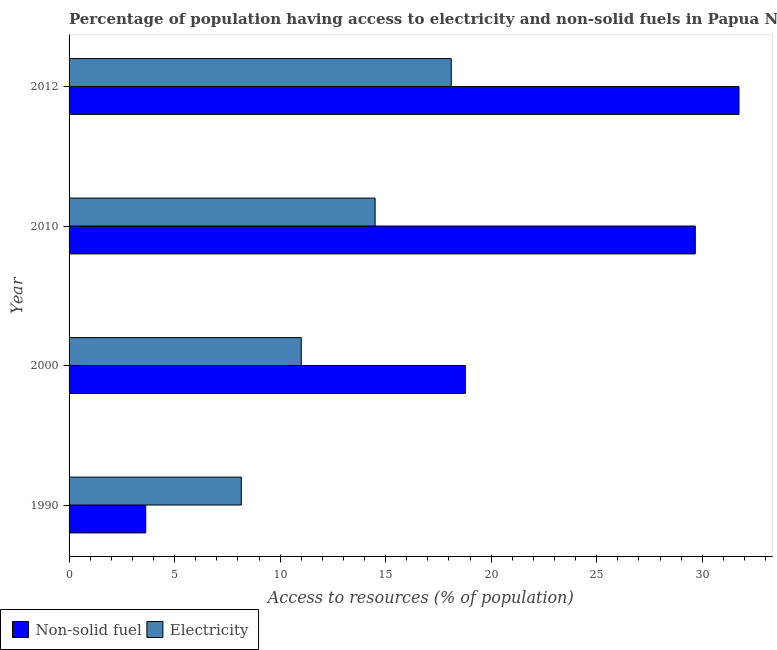How many different coloured bars are there?
Your response must be concise. 2. Are the number of bars on each tick of the Y-axis equal?
Your answer should be compact. Yes. How many bars are there on the 2nd tick from the bottom?
Provide a short and direct response. 2. What is the percentage of population having access to non-solid fuel in 2010?
Provide a short and direct response. 29.67. Across all years, what is the maximum percentage of population having access to electricity?
Make the answer very short. 18.11. Across all years, what is the minimum percentage of population having access to electricity?
Ensure brevity in your answer.  8.16. What is the total percentage of population having access to electricity in the graph?
Your answer should be compact. 51.77. What is the difference between the percentage of population having access to electricity in 1990 and that in 2000?
Keep it short and to the point. -2.84. What is the difference between the percentage of population having access to non-solid fuel in 2000 and the percentage of population having access to electricity in 2010?
Keep it short and to the point. 4.27. What is the average percentage of population having access to electricity per year?
Ensure brevity in your answer.  12.94. In the year 2010, what is the difference between the percentage of population having access to electricity and percentage of population having access to non-solid fuel?
Provide a short and direct response. -15.17. In how many years, is the percentage of population having access to non-solid fuel greater than 20 %?
Provide a succinct answer. 2. What is the ratio of the percentage of population having access to electricity in 1990 to that in 2000?
Provide a short and direct response. 0.74. Is the percentage of population having access to non-solid fuel in 2010 less than that in 2012?
Offer a very short reply. Yes. Is the difference between the percentage of population having access to electricity in 2000 and 2012 greater than the difference between the percentage of population having access to non-solid fuel in 2000 and 2012?
Keep it short and to the point. Yes. What is the difference between the highest and the second highest percentage of population having access to electricity?
Make the answer very short. 3.61. What is the difference between the highest and the lowest percentage of population having access to electricity?
Make the answer very short. 9.95. Is the sum of the percentage of population having access to non-solid fuel in 2000 and 2010 greater than the maximum percentage of population having access to electricity across all years?
Offer a very short reply. Yes. What does the 2nd bar from the top in 2000 represents?
Your answer should be very brief. Non-solid fuel. What does the 2nd bar from the bottom in 2010 represents?
Your answer should be compact. Electricity. How many bars are there?
Ensure brevity in your answer.  8. Are all the bars in the graph horizontal?
Provide a succinct answer. Yes. Are the values on the major ticks of X-axis written in scientific E-notation?
Ensure brevity in your answer.  No. Does the graph contain any zero values?
Your answer should be very brief. No. Does the graph contain grids?
Make the answer very short. No. Where does the legend appear in the graph?
Keep it short and to the point. Bottom left. How are the legend labels stacked?
Offer a terse response. Horizontal. What is the title of the graph?
Offer a very short reply. Percentage of population having access to electricity and non-solid fuels in Papua New Guinea. What is the label or title of the X-axis?
Your answer should be compact. Access to resources (% of population). What is the label or title of the Y-axis?
Offer a very short reply. Year. What is the Access to resources (% of population) in Non-solid fuel in 1990?
Offer a very short reply. 3.63. What is the Access to resources (% of population) in Electricity in 1990?
Your answer should be compact. 8.16. What is the Access to resources (% of population) of Non-solid fuel in 2000?
Make the answer very short. 18.77. What is the Access to resources (% of population) in Electricity in 2000?
Offer a very short reply. 11. What is the Access to resources (% of population) in Non-solid fuel in 2010?
Provide a succinct answer. 29.67. What is the Access to resources (% of population) in Non-solid fuel in 2012?
Offer a terse response. 31.74. What is the Access to resources (% of population) of Electricity in 2012?
Your response must be concise. 18.11. Across all years, what is the maximum Access to resources (% of population) in Non-solid fuel?
Provide a succinct answer. 31.74. Across all years, what is the maximum Access to resources (% of population) in Electricity?
Your response must be concise. 18.11. Across all years, what is the minimum Access to resources (% of population) of Non-solid fuel?
Make the answer very short. 3.63. Across all years, what is the minimum Access to resources (% of population) of Electricity?
Ensure brevity in your answer.  8.16. What is the total Access to resources (% of population) in Non-solid fuel in the graph?
Make the answer very short. 83.81. What is the total Access to resources (% of population) of Electricity in the graph?
Your answer should be very brief. 51.77. What is the difference between the Access to resources (% of population) of Non-solid fuel in 1990 and that in 2000?
Offer a very short reply. -15.14. What is the difference between the Access to resources (% of population) in Electricity in 1990 and that in 2000?
Offer a terse response. -2.84. What is the difference between the Access to resources (% of population) in Non-solid fuel in 1990 and that in 2010?
Keep it short and to the point. -26.04. What is the difference between the Access to resources (% of population) of Electricity in 1990 and that in 2010?
Provide a succinct answer. -6.34. What is the difference between the Access to resources (% of population) in Non-solid fuel in 1990 and that in 2012?
Your answer should be very brief. -28.11. What is the difference between the Access to resources (% of population) of Electricity in 1990 and that in 2012?
Provide a short and direct response. -9.95. What is the difference between the Access to resources (% of population) of Non-solid fuel in 2000 and that in 2010?
Keep it short and to the point. -10.9. What is the difference between the Access to resources (% of population) in Electricity in 2000 and that in 2010?
Offer a terse response. -3.5. What is the difference between the Access to resources (% of population) in Non-solid fuel in 2000 and that in 2012?
Offer a very short reply. -12.97. What is the difference between the Access to resources (% of population) of Electricity in 2000 and that in 2012?
Your answer should be very brief. -7.11. What is the difference between the Access to resources (% of population) in Non-solid fuel in 2010 and that in 2012?
Keep it short and to the point. -2.07. What is the difference between the Access to resources (% of population) of Electricity in 2010 and that in 2012?
Keep it short and to the point. -3.61. What is the difference between the Access to resources (% of population) in Non-solid fuel in 1990 and the Access to resources (% of population) in Electricity in 2000?
Your answer should be compact. -7.37. What is the difference between the Access to resources (% of population) of Non-solid fuel in 1990 and the Access to resources (% of population) of Electricity in 2010?
Ensure brevity in your answer.  -10.87. What is the difference between the Access to resources (% of population) of Non-solid fuel in 1990 and the Access to resources (% of population) of Electricity in 2012?
Offer a very short reply. -14.48. What is the difference between the Access to resources (% of population) of Non-solid fuel in 2000 and the Access to resources (% of population) of Electricity in 2010?
Provide a succinct answer. 4.27. What is the difference between the Access to resources (% of population) in Non-solid fuel in 2000 and the Access to resources (% of population) in Electricity in 2012?
Keep it short and to the point. 0.67. What is the difference between the Access to resources (% of population) in Non-solid fuel in 2010 and the Access to resources (% of population) in Electricity in 2012?
Offer a very short reply. 11.56. What is the average Access to resources (% of population) in Non-solid fuel per year?
Offer a terse response. 20.95. What is the average Access to resources (% of population) of Electricity per year?
Provide a short and direct response. 12.94. In the year 1990, what is the difference between the Access to resources (% of population) in Non-solid fuel and Access to resources (% of population) in Electricity?
Offer a very short reply. -4.53. In the year 2000, what is the difference between the Access to resources (% of population) in Non-solid fuel and Access to resources (% of population) in Electricity?
Ensure brevity in your answer.  7.77. In the year 2010, what is the difference between the Access to resources (% of population) in Non-solid fuel and Access to resources (% of population) in Electricity?
Your answer should be very brief. 15.17. In the year 2012, what is the difference between the Access to resources (% of population) of Non-solid fuel and Access to resources (% of population) of Electricity?
Offer a terse response. 13.63. What is the ratio of the Access to resources (% of population) of Non-solid fuel in 1990 to that in 2000?
Your answer should be compact. 0.19. What is the ratio of the Access to resources (% of population) in Electricity in 1990 to that in 2000?
Provide a succinct answer. 0.74. What is the ratio of the Access to resources (% of population) of Non-solid fuel in 1990 to that in 2010?
Offer a very short reply. 0.12. What is the ratio of the Access to resources (% of population) of Electricity in 1990 to that in 2010?
Give a very brief answer. 0.56. What is the ratio of the Access to resources (% of population) in Non-solid fuel in 1990 to that in 2012?
Offer a very short reply. 0.11. What is the ratio of the Access to resources (% of population) in Electricity in 1990 to that in 2012?
Offer a very short reply. 0.45. What is the ratio of the Access to resources (% of population) in Non-solid fuel in 2000 to that in 2010?
Offer a very short reply. 0.63. What is the ratio of the Access to resources (% of population) in Electricity in 2000 to that in 2010?
Your answer should be very brief. 0.76. What is the ratio of the Access to resources (% of population) in Non-solid fuel in 2000 to that in 2012?
Make the answer very short. 0.59. What is the ratio of the Access to resources (% of population) in Electricity in 2000 to that in 2012?
Your answer should be very brief. 0.61. What is the ratio of the Access to resources (% of population) in Non-solid fuel in 2010 to that in 2012?
Keep it short and to the point. 0.93. What is the ratio of the Access to resources (% of population) in Electricity in 2010 to that in 2012?
Provide a succinct answer. 0.8. What is the difference between the highest and the second highest Access to resources (% of population) in Non-solid fuel?
Provide a succinct answer. 2.07. What is the difference between the highest and the second highest Access to resources (% of population) of Electricity?
Make the answer very short. 3.61. What is the difference between the highest and the lowest Access to resources (% of population) in Non-solid fuel?
Provide a succinct answer. 28.11. What is the difference between the highest and the lowest Access to resources (% of population) of Electricity?
Your answer should be very brief. 9.95. 